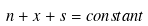Convert formula to latex. <formula><loc_0><loc_0><loc_500><loc_500>n + x + s = c o n s t a n t</formula> 